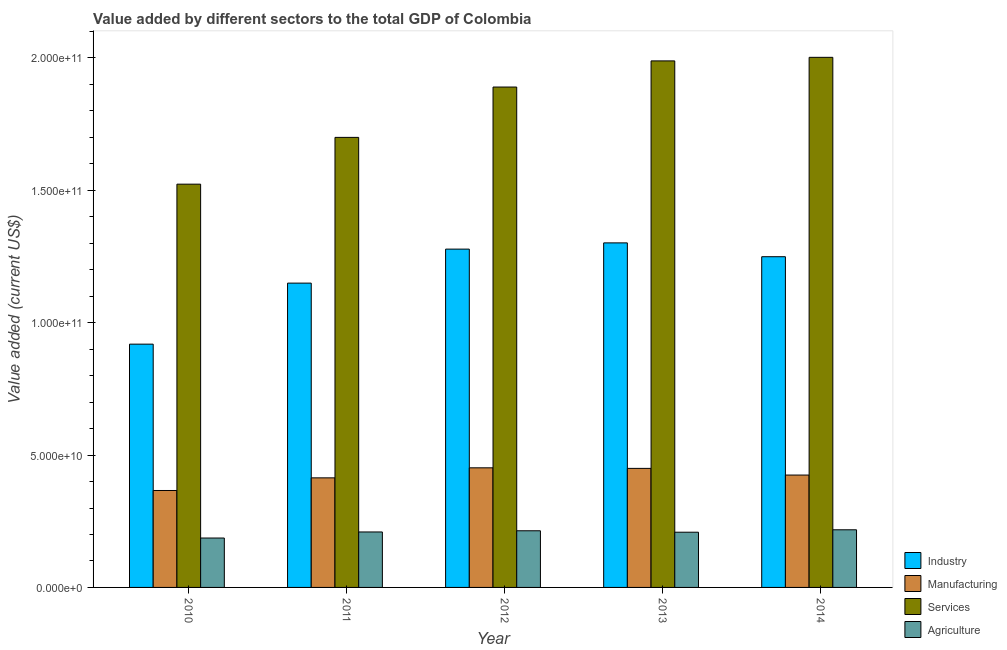How many different coloured bars are there?
Ensure brevity in your answer.  4. How many groups of bars are there?
Make the answer very short. 5. Are the number of bars on each tick of the X-axis equal?
Provide a short and direct response. Yes. How many bars are there on the 3rd tick from the left?
Your answer should be very brief. 4. How many bars are there on the 5th tick from the right?
Give a very brief answer. 4. What is the label of the 1st group of bars from the left?
Ensure brevity in your answer.  2010. In how many cases, is the number of bars for a given year not equal to the number of legend labels?
Provide a short and direct response. 0. What is the value added by agricultural sector in 2013?
Your answer should be compact. 2.09e+1. Across all years, what is the maximum value added by agricultural sector?
Your response must be concise. 2.18e+1. Across all years, what is the minimum value added by services sector?
Make the answer very short. 1.52e+11. What is the total value added by industrial sector in the graph?
Make the answer very short. 5.90e+11. What is the difference between the value added by services sector in 2010 and that in 2013?
Keep it short and to the point. -4.66e+1. What is the difference between the value added by agricultural sector in 2014 and the value added by services sector in 2011?
Keep it short and to the point. 8.23e+08. What is the average value added by services sector per year?
Provide a succinct answer. 1.82e+11. In the year 2012, what is the difference between the value added by agricultural sector and value added by industrial sector?
Make the answer very short. 0. In how many years, is the value added by agricultural sector greater than 60000000000 US$?
Give a very brief answer. 0. What is the ratio of the value added by manufacturing sector in 2011 to that in 2014?
Your answer should be compact. 0.98. What is the difference between the highest and the second highest value added by agricultural sector?
Provide a short and direct response. 3.77e+08. What is the difference between the highest and the lowest value added by industrial sector?
Keep it short and to the point. 3.83e+1. In how many years, is the value added by agricultural sector greater than the average value added by agricultural sector taken over all years?
Give a very brief answer. 4. Is the sum of the value added by industrial sector in 2011 and 2013 greater than the maximum value added by agricultural sector across all years?
Give a very brief answer. Yes. Is it the case that in every year, the sum of the value added by agricultural sector and value added by industrial sector is greater than the sum of value added by manufacturing sector and value added by services sector?
Your answer should be very brief. No. What does the 3rd bar from the left in 2010 represents?
Provide a short and direct response. Services. What does the 3rd bar from the right in 2011 represents?
Give a very brief answer. Manufacturing. How many years are there in the graph?
Ensure brevity in your answer.  5. What is the difference between two consecutive major ticks on the Y-axis?
Make the answer very short. 5.00e+1. Does the graph contain any zero values?
Give a very brief answer. No. Where does the legend appear in the graph?
Ensure brevity in your answer.  Bottom right. What is the title of the graph?
Make the answer very short. Value added by different sectors to the total GDP of Colombia. Does "Public sector management" appear as one of the legend labels in the graph?
Make the answer very short. No. What is the label or title of the Y-axis?
Offer a very short reply. Value added (current US$). What is the Value added (current US$) of Industry in 2010?
Your answer should be compact. 9.19e+1. What is the Value added (current US$) in Manufacturing in 2010?
Keep it short and to the point. 3.66e+1. What is the Value added (current US$) of Services in 2010?
Offer a very short reply. 1.52e+11. What is the Value added (current US$) in Agriculture in 2010?
Provide a short and direct response. 1.87e+1. What is the Value added (current US$) in Industry in 2011?
Provide a succinct answer. 1.15e+11. What is the Value added (current US$) in Manufacturing in 2011?
Provide a short and direct response. 4.14e+1. What is the Value added (current US$) of Services in 2011?
Keep it short and to the point. 1.70e+11. What is the Value added (current US$) of Agriculture in 2011?
Offer a terse response. 2.10e+1. What is the Value added (current US$) of Industry in 2012?
Ensure brevity in your answer.  1.28e+11. What is the Value added (current US$) in Manufacturing in 2012?
Offer a very short reply. 4.52e+1. What is the Value added (current US$) of Services in 2012?
Offer a very short reply. 1.89e+11. What is the Value added (current US$) of Agriculture in 2012?
Your answer should be very brief. 2.14e+1. What is the Value added (current US$) of Industry in 2013?
Your response must be concise. 1.30e+11. What is the Value added (current US$) in Manufacturing in 2013?
Make the answer very short. 4.50e+1. What is the Value added (current US$) of Services in 2013?
Your response must be concise. 1.99e+11. What is the Value added (current US$) of Agriculture in 2013?
Ensure brevity in your answer.  2.09e+1. What is the Value added (current US$) of Industry in 2014?
Your answer should be compact. 1.25e+11. What is the Value added (current US$) of Manufacturing in 2014?
Give a very brief answer. 4.25e+1. What is the Value added (current US$) of Services in 2014?
Your response must be concise. 2.00e+11. What is the Value added (current US$) in Agriculture in 2014?
Your answer should be compact. 2.18e+1. Across all years, what is the maximum Value added (current US$) of Industry?
Offer a terse response. 1.30e+11. Across all years, what is the maximum Value added (current US$) of Manufacturing?
Your answer should be very brief. 4.52e+1. Across all years, what is the maximum Value added (current US$) in Services?
Your answer should be very brief. 2.00e+11. Across all years, what is the maximum Value added (current US$) of Agriculture?
Provide a short and direct response. 2.18e+1. Across all years, what is the minimum Value added (current US$) of Industry?
Offer a very short reply. 9.19e+1. Across all years, what is the minimum Value added (current US$) in Manufacturing?
Give a very brief answer. 3.66e+1. Across all years, what is the minimum Value added (current US$) of Services?
Your response must be concise. 1.52e+11. Across all years, what is the minimum Value added (current US$) in Agriculture?
Keep it short and to the point. 1.87e+1. What is the total Value added (current US$) of Industry in the graph?
Your answer should be very brief. 5.90e+11. What is the total Value added (current US$) in Manufacturing in the graph?
Provide a short and direct response. 2.11e+11. What is the total Value added (current US$) in Services in the graph?
Offer a terse response. 9.11e+11. What is the total Value added (current US$) in Agriculture in the graph?
Give a very brief answer. 1.04e+11. What is the difference between the Value added (current US$) of Industry in 2010 and that in 2011?
Ensure brevity in your answer.  -2.31e+1. What is the difference between the Value added (current US$) of Manufacturing in 2010 and that in 2011?
Offer a terse response. -4.77e+09. What is the difference between the Value added (current US$) of Services in 2010 and that in 2011?
Provide a succinct answer. -1.77e+1. What is the difference between the Value added (current US$) in Agriculture in 2010 and that in 2011?
Keep it short and to the point. -2.29e+09. What is the difference between the Value added (current US$) in Industry in 2010 and that in 2012?
Give a very brief answer. -3.59e+1. What is the difference between the Value added (current US$) of Manufacturing in 2010 and that in 2012?
Offer a terse response. -8.56e+09. What is the difference between the Value added (current US$) in Services in 2010 and that in 2012?
Make the answer very short. -3.67e+1. What is the difference between the Value added (current US$) in Agriculture in 2010 and that in 2012?
Offer a very short reply. -2.74e+09. What is the difference between the Value added (current US$) of Industry in 2010 and that in 2013?
Provide a short and direct response. -3.83e+1. What is the difference between the Value added (current US$) of Manufacturing in 2010 and that in 2013?
Ensure brevity in your answer.  -8.35e+09. What is the difference between the Value added (current US$) of Services in 2010 and that in 2013?
Offer a very short reply. -4.66e+1. What is the difference between the Value added (current US$) of Agriculture in 2010 and that in 2013?
Provide a succinct answer. -2.20e+09. What is the difference between the Value added (current US$) in Industry in 2010 and that in 2014?
Ensure brevity in your answer.  -3.30e+1. What is the difference between the Value added (current US$) in Manufacturing in 2010 and that in 2014?
Offer a very short reply. -5.83e+09. What is the difference between the Value added (current US$) of Services in 2010 and that in 2014?
Offer a very short reply. -4.79e+1. What is the difference between the Value added (current US$) of Agriculture in 2010 and that in 2014?
Provide a succinct answer. -3.11e+09. What is the difference between the Value added (current US$) of Industry in 2011 and that in 2012?
Provide a succinct answer. -1.28e+1. What is the difference between the Value added (current US$) of Manufacturing in 2011 and that in 2012?
Provide a short and direct response. -3.79e+09. What is the difference between the Value added (current US$) in Services in 2011 and that in 2012?
Your response must be concise. -1.90e+1. What is the difference between the Value added (current US$) of Agriculture in 2011 and that in 2012?
Your response must be concise. -4.47e+08. What is the difference between the Value added (current US$) in Industry in 2011 and that in 2013?
Provide a succinct answer. -1.52e+1. What is the difference between the Value added (current US$) of Manufacturing in 2011 and that in 2013?
Offer a very short reply. -3.58e+09. What is the difference between the Value added (current US$) of Services in 2011 and that in 2013?
Make the answer very short. -2.89e+1. What is the difference between the Value added (current US$) in Agriculture in 2011 and that in 2013?
Offer a very short reply. 9.45e+07. What is the difference between the Value added (current US$) of Industry in 2011 and that in 2014?
Your answer should be very brief. -9.98e+09. What is the difference between the Value added (current US$) of Manufacturing in 2011 and that in 2014?
Your answer should be compact. -1.06e+09. What is the difference between the Value added (current US$) of Services in 2011 and that in 2014?
Provide a short and direct response. -3.02e+1. What is the difference between the Value added (current US$) of Agriculture in 2011 and that in 2014?
Offer a very short reply. -8.23e+08. What is the difference between the Value added (current US$) in Industry in 2012 and that in 2013?
Provide a succinct answer. -2.36e+09. What is the difference between the Value added (current US$) in Manufacturing in 2012 and that in 2013?
Give a very brief answer. 2.10e+08. What is the difference between the Value added (current US$) in Services in 2012 and that in 2013?
Your answer should be compact. -9.87e+09. What is the difference between the Value added (current US$) of Agriculture in 2012 and that in 2013?
Provide a short and direct response. 5.41e+08. What is the difference between the Value added (current US$) in Industry in 2012 and that in 2014?
Offer a very short reply. 2.87e+09. What is the difference between the Value added (current US$) in Manufacturing in 2012 and that in 2014?
Offer a very short reply. 2.73e+09. What is the difference between the Value added (current US$) of Services in 2012 and that in 2014?
Make the answer very short. -1.12e+1. What is the difference between the Value added (current US$) in Agriculture in 2012 and that in 2014?
Ensure brevity in your answer.  -3.77e+08. What is the difference between the Value added (current US$) of Industry in 2013 and that in 2014?
Make the answer very short. 5.22e+09. What is the difference between the Value added (current US$) in Manufacturing in 2013 and that in 2014?
Your answer should be compact. 2.52e+09. What is the difference between the Value added (current US$) in Services in 2013 and that in 2014?
Keep it short and to the point. -1.35e+09. What is the difference between the Value added (current US$) in Agriculture in 2013 and that in 2014?
Provide a succinct answer. -9.18e+08. What is the difference between the Value added (current US$) of Industry in 2010 and the Value added (current US$) of Manufacturing in 2011?
Provide a short and direct response. 5.05e+1. What is the difference between the Value added (current US$) in Industry in 2010 and the Value added (current US$) in Services in 2011?
Provide a succinct answer. -7.81e+1. What is the difference between the Value added (current US$) in Industry in 2010 and the Value added (current US$) in Agriculture in 2011?
Provide a short and direct response. 7.10e+1. What is the difference between the Value added (current US$) in Manufacturing in 2010 and the Value added (current US$) in Services in 2011?
Ensure brevity in your answer.  -1.33e+11. What is the difference between the Value added (current US$) of Manufacturing in 2010 and the Value added (current US$) of Agriculture in 2011?
Your answer should be compact. 1.57e+1. What is the difference between the Value added (current US$) of Services in 2010 and the Value added (current US$) of Agriculture in 2011?
Keep it short and to the point. 1.31e+11. What is the difference between the Value added (current US$) of Industry in 2010 and the Value added (current US$) of Manufacturing in 2012?
Keep it short and to the point. 4.67e+1. What is the difference between the Value added (current US$) in Industry in 2010 and the Value added (current US$) in Services in 2012?
Make the answer very short. -9.71e+1. What is the difference between the Value added (current US$) of Industry in 2010 and the Value added (current US$) of Agriculture in 2012?
Offer a very short reply. 7.05e+1. What is the difference between the Value added (current US$) of Manufacturing in 2010 and the Value added (current US$) of Services in 2012?
Offer a terse response. -1.52e+11. What is the difference between the Value added (current US$) of Manufacturing in 2010 and the Value added (current US$) of Agriculture in 2012?
Offer a terse response. 1.52e+1. What is the difference between the Value added (current US$) in Services in 2010 and the Value added (current US$) in Agriculture in 2012?
Provide a succinct answer. 1.31e+11. What is the difference between the Value added (current US$) in Industry in 2010 and the Value added (current US$) in Manufacturing in 2013?
Provide a succinct answer. 4.69e+1. What is the difference between the Value added (current US$) of Industry in 2010 and the Value added (current US$) of Services in 2013?
Keep it short and to the point. -1.07e+11. What is the difference between the Value added (current US$) in Industry in 2010 and the Value added (current US$) in Agriculture in 2013?
Offer a terse response. 7.10e+1. What is the difference between the Value added (current US$) in Manufacturing in 2010 and the Value added (current US$) in Services in 2013?
Your response must be concise. -1.62e+11. What is the difference between the Value added (current US$) of Manufacturing in 2010 and the Value added (current US$) of Agriculture in 2013?
Your response must be concise. 1.58e+1. What is the difference between the Value added (current US$) in Services in 2010 and the Value added (current US$) in Agriculture in 2013?
Your answer should be very brief. 1.31e+11. What is the difference between the Value added (current US$) of Industry in 2010 and the Value added (current US$) of Manufacturing in 2014?
Ensure brevity in your answer.  4.95e+1. What is the difference between the Value added (current US$) in Industry in 2010 and the Value added (current US$) in Services in 2014?
Provide a short and direct response. -1.08e+11. What is the difference between the Value added (current US$) of Industry in 2010 and the Value added (current US$) of Agriculture in 2014?
Provide a short and direct response. 7.01e+1. What is the difference between the Value added (current US$) in Manufacturing in 2010 and the Value added (current US$) in Services in 2014?
Offer a terse response. -1.64e+11. What is the difference between the Value added (current US$) of Manufacturing in 2010 and the Value added (current US$) of Agriculture in 2014?
Offer a terse response. 1.48e+1. What is the difference between the Value added (current US$) of Services in 2010 and the Value added (current US$) of Agriculture in 2014?
Make the answer very short. 1.31e+11. What is the difference between the Value added (current US$) of Industry in 2011 and the Value added (current US$) of Manufacturing in 2012?
Give a very brief answer. 6.98e+1. What is the difference between the Value added (current US$) in Industry in 2011 and the Value added (current US$) in Services in 2012?
Provide a short and direct response. -7.41e+1. What is the difference between the Value added (current US$) of Industry in 2011 and the Value added (current US$) of Agriculture in 2012?
Offer a terse response. 9.36e+1. What is the difference between the Value added (current US$) of Manufacturing in 2011 and the Value added (current US$) of Services in 2012?
Keep it short and to the point. -1.48e+11. What is the difference between the Value added (current US$) of Manufacturing in 2011 and the Value added (current US$) of Agriculture in 2012?
Provide a short and direct response. 2.00e+1. What is the difference between the Value added (current US$) of Services in 2011 and the Value added (current US$) of Agriculture in 2012?
Ensure brevity in your answer.  1.49e+11. What is the difference between the Value added (current US$) of Industry in 2011 and the Value added (current US$) of Manufacturing in 2013?
Make the answer very short. 7.00e+1. What is the difference between the Value added (current US$) in Industry in 2011 and the Value added (current US$) in Services in 2013?
Provide a short and direct response. -8.39e+1. What is the difference between the Value added (current US$) of Industry in 2011 and the Value added (current US$) of Agriculture in 2013?
Keep it short and to the point. 9.41e+1. What is the difference between the Value added (current US$) in Manufacturing in 2011 and the Value added (current US$) in Services in 2013?
Give a very brief answer. -1.58e+11. What is the difference between the Value added (current US$) in Manufacturing in 2011 and the Value added (current US$) in Agriculture in 2013?
Keep it short and to the point. 2.05e+1. What is the difference between the Value added (current US$) of Services in 2011 and the Value added (current US$) of Agriculture in 2013?
Offer a terse response. 1.49e+11. What is the difference between the Value added (current US$) in Industry in 2011 and the Value added (current US$) in Manufacturing in 2014?
Make the answer very short. 7.25e+1. What is the difference between the Value added (current US$) in Industry in 2011 and the Value added (current US$) in Services in 2014?
Your response must be concise. -8.53e+1. What is the difference between the Value added (current US$) in Industry in 2011 and the Value added (current US$) in Agriculture in 2014?
Ensure brevity in your answer.  9.32e+1. What is the difference between the Value added (current US$) of Manufacturing in 2011 and the Value added (current US$) of Services in 2014?
Provide a succinct answer. -1.59e+11. What is the difference between the Value added (current US$) in Manufacturing in 2011 and the Value added (current US$) in Agriculture in 2014?
Offer a very short reply. 1.96e+1. What is the difference between the Value added (current US$) of Services in 2011 and the Value added (current US$) of Agriculture in 2014?
Your response must be concise. 1.48e+11. What is the difference between the Value added (current US$) of Industry in 2012 and the Value added (current US$) of Manufacturing in 2013?
Make the answer very short. 8.28e+1. What is the difference between the Value added (current US$) in Industry in 2012 and the Value added (current US$) in Services in 2013?
Your answer should be compact. -7.11e+1. What is the difference between the Value added (current US$) of Industry in 2012 and the Value added (current US$) of Agriculture in 2013?
Make the answer very short. 1.07e+11. What is the difference between the Value added (current US$) in Manufacturing in 2012 and the Value added (current US$) in Services in 2013?
Your answer should be very brief. -1.54e+11. What is the difference between the Value added (current US$) in Manufacturing in 2012 and the Value added (current US$) in Agriculture in 2013?
Keep it short and to the point. 2.43e+1. What is the difference between the Value added (current US$) in Services in 2012 and the Value added (current US$) in Agriculture in 2013?
Your answer should be compact. 1.68e+11. What is the difference between the Value added (current US$) in Industry in 2012 and the Value added (current US$) in Manufacturing in 2014?
Ensure brevity in your answer.  8.53e+1. What is the difference between the Value added (current US$) of Industry in 2012 and the Value added (current US$) of Services in 2014?
Offer a very short reply. -7.25e+1. What is the difference between the Value added (current US$) in Industry in 2012 and the Value added (current US$) in Agriculture in 2014?
Ensure brevity in your answer.  1.06e+11. What is the difference between the Value added (current US$) of Manufacturing in 2012 and the Value added (current US$) of Services in 2014?
Keep it short and to the point. -1.55e+11. What is the difference between the Value added (current US$) in Manufacturing in 2012 and the Value added (current US$) in Agriculture in 2014?
Your answer should be compact. 2.34e+1. What is the difference between the Value added (current US$) in Services in 2012 and the Value added (current US$) in Agriculture in 2014?
Your answer should be very brief. 1.67e+11. What is the difference between the Value added (current US$) of Industry in 2013 and the Value added (current US$) of Manufacturing in 2014?
Your response must be concise. 8.77e+1. What is the difference between the Value added (current US$) of Industry in 2013 and the Value added (current US$) of Services in 2014?
Your answer should be very brief. -7.01e+1. What is the difference between the Value added (current US$) in Industry in 2013 and the Value added (current US$) in Agriculture in 2014?
Provide a short and direct response. 1.08e+11. What is the difference between the Value added (current US$) of Manufacturing in 2013 and the Value added (current US$) of Services in 2014?
Your answer should be compact. -1.55e+11. What is the difference between the Value added (current US$) of Manufacturing in 2013 and the Value added (current US$) of Agriculture in 2014?
Your answer should be very brief. 2.32e+1. What is the difference between the Value added (current US$) of Services in 2013 and the Value added (current US$) of Agriculture in 2014?
Your answer should be compact. 1.77e+11. What is the average Value added (current US$) of Industry per year?
Offer a terse response. 1.18e+11. What is the average Value added (current US$) in Manufacturing per year?
Provide a succinct answer. 4.21e+1. What is the average Value added (current US$) of Services per year?
Provide a succinct answer. 1.82e+11. What is the average Value added (current US$) of Agriculture per year?
Offer a terse response. 2.07e+1. In the year 2010, what is the difference between the Value added (current US$) in Industry and Value added (current US$) in Manufacturing?
Keep it short and to the point. 5.53e+1. In the year 2010, what is the difference between the Value added (current US$) in Industry and Value added (current US$) in Services?
Offer a terse response. -6.04e+1. In the year 2010, what is the difference between the Value added (current US$) in Industry and Value added (current US$) in Agriculture?
Your answer should be very brief. 7.32e+1. In the year 2010, what is the difference between the Value added (current US$) of Manufacturing and Value added (current US$) of Services?
Offer a very short reply. -1.16e+11. In the year 2010, what is the difference between the Value added (current US$) in Manufacturing and Value added (current US$) in Agriculture?
Keep it short and to the point. 1.80e+1. In the year 2010, what is the difference between the Value added (current US$) of Services and Value added (current US$) of Agriculture?
Provide a short and direct response. 1.34e+11. In the year 2011, what is the difference between the Value added (current US$) of Industry and Value added (current US$) of Manufacturing?
Provide a short and direct response. 7.36e+1. In the year 2011, what is the difference between the Value added (current US$) in Industry and Value added (current US$) in Services?
Keep it short and to the point. -5.51e+1. In the year 2011, what is the difference between the Value added (current US$) in Industry and Value added (current US$) in Agriculture?
Your answer should be very brief. 9.40e+1. In the year 2011, what is the difference between the Value added (current US$) in Manufacturing and Value added (current US$) in Services?
Provide a short and direct response. -1.29e+11. In the year 2011, what is the difference between the Value added (current US$) of Manufacturing and Value added (current US$) of Agriculture?
Give a very brief answer. 2.04e+1. In the year 2011, what is the difference between the Value added (current US$) of Services and Value added (current US$) of Agriculture?
Ensure brevity in your answer.  1.49e+11. In the year 2012, what is the difference between the Value added (current US$) in Industry and Value added (current US$) in Manufacturing?
Offer a terse response. 8.26e+1. In the year 2012, what is the difference between the Value added (current US$) in Industry and Value added (current US$) in Services?
Make the answer very short. -6.12e+1. In the year 2012, what is the difference between the Value added (current US$) in Industry and Value added (current US$) in Agriculture?
Offer a terse response. 1.06e+11. In the year 2012, what is the difference between the Value added (current US$) of Manufacturing and Value added (current US$) of Services?
Provide a succinct answer. -1.44e+11. In the year 2012, what is the difference between the Value added (current US$) in Manufacturing and Value added (current US$) in Agriculture?
Your answer should be compact. 2.38e+1. In the year 2012, what is the difference between the Value added (current US$) in Services and Value added (current US$) in Agriculture?
Offer a very short reply. 1.68e+11. In the year 2013, what is the difference between the Value added (current US$) in Industry and Value added (current US$) in Manufacturing?
Offer a terse response. 8.52e+1. In the year 2013, what is the difference between the Value added (current US$) in Industry and Value added (current US$) in Services?
Provide a succinct answer. -6.87e+1. In the year 2013, what is the difference between the Value added (current US$) in Industry and Value added (current US$) in Agriculture?
Give a very brief answer. 1.09e+11. In the year 2013, what is the difference between the Value added (current US$) of Manufacturing and Value added (current US$) of Services?
Your answer should be compact. -1.54e+11. In the year 2013, what is the difference between the Value added (current US$) in Manufacturing and Value added (current US$) in Agriculture?
Your answer should be very brief. 2.41e+1. In the year 2013, what is the difference between the Value added (current US$) in Services and Value added (current US$) in Agriculture?
Offer a terse response. 1.78e+11. In the year 2014, what is the difference between the Value added (current US$) in Industry and Value added (current US$) in Manufacturing?
Make the answer very short. 8.25e+1. In the year 2014, what is the difference between the Value added (current US$) in Industry and Value added (current US$) in Services?
Offer a terse response. -7.53e+1. In the year 2014, what is the difference between the Value added (current US$) of Industry and Value added (current US$) of Agriculture?
Your answer should be very brief. 1.03e+11. In the year 2014, what is the difference between the Value added (current US$) in Manufacturing and Value added (current US$) in Services?
Keep it short and to the point. -1.58e+11. In the year 2014, what is the difference between the Value added (current US$) of Manufacturing and Value added (current US$) of Agriculture?
Your answer should be very brief. 2.07e+1. In the year 2014, what is the difference between the Value added (current US$) of Services and Value added (current US$) of Agriculture?
Give a very brief answer. 1.78e+11. What is the ratio of the Value added (current US$) in Industry in 2010 to that in 2011?
Offer a very short reply. 0.8. What is the ratio of the Value added (current US$) of Manufacturing in 2010 to that in 2011?
Your answer should be very brief. 0.88. What is the ratio of the Value added (current US$) of Services in 2010 to that in 2011?
Give a very brief answer. 0.9. What is the ratio of the Value added (current US$) of Agriculture in 2010 to that in 2011?
Make the answer very short. 0.89. What is the ratio of the Value added (current US$) in Industry in 2010 to that in 2012?
Offer a very short reply. 0.72. What is the ratio of the Value added (current US$) of Manufacturing in 2010 to that in 2012?
Offer a terse response. 0.81. What is the ratio of the Value added (current US$) in Services in 2010 to that in 2012?
Your response must be concise. 0.81. What is the ratio of the Value added (current US$) in Agriculture in 2010 to that in 2012?
Ensure brevity in your answer.  0.87. What is the ratio of the Value added (current US$) of Industry in 2010 to that in 2013?
Your response must be concise. 0.71. What is the ratio of the Value added (current US$) of Manufacturing in 2010 to that in 2013?
Provide a short and direct response. 0.81. What is the ratio of the Value added (current US$) of Services in 2010 to that in 2013?
Make the answer very short. 0.77. What is the ratio of the Value added (current US$) in Agriculture in 2010 to that in 2013?
Provide a short and direct response. 0.89. What is the ratio of the Value added (current US$) of Industry in 2010 to that in 2014?
Your answer should be compact. 0.74. What is the ratio of the Value added (current US$) in Manufacturing in 2010 to that in 2014?
Your response must be concise. 0.86. What is the ratio of the Value added (current US$) in Services in 2010 to that in 2014?
Provide a succinct answer. 0.76. What is the ratio of the Value added (current US$) in Agriculture in 2010 to that in 2014?
Ensure brevity in your answer.  0.86. What is the ratio of the Value added (current US$) in Industry in 2011 to that in 2012?
Your answer should be very brief. 0.9. What is the ratio of the Value added (current US$) of Manufacturing in 2011 to that in 2012?
Your answer should be very brief. 0.92. What is the ratio of the Value added (current US$) of Services in 2011 to that in 2012?
Make the answer very short. 0.9. What is the ratio of the Value added (current US$) in Agriculture in 2011 to that in 2012?
Make the answer very short. 0.98. What is the ratio of the Value added (current US$) in Industry in 2011 to that in 2013?
Ensure brevity in your answer.  0.88. What is the ratio of the Value added (current US$) in Manufacturing in 2011 to that in 2013?
Provide a succinct answer. 0.92. What is the ratio of the Value added (current US$) in Services in 2011 to that in 2013?
Give a very brief answer. 0.85. What is the ratio of the Value added (current US$) of Agriculture in 2011 to that in 2013?
Your response must be concise. 1. What is the ratio of the Value added (current US$) of Industry in 2011 to that in 2014?
Offer a terse response. 0.92. What is the ratio of the Value added (current US$) in Manufacturing in 2011 to that in 2014?
Offer a very short reply. 0.97. What is the ratio of the Value added (current US$) in Services in 2011 to that in 2014?
Keep it short and to the point. 0.85. What is the ratio of the Value added (current US$) in Agriculture in 2011 to that in 2014?
Make the answer very short. 0.96. What is the ratio of the Value added (current US$) in Industry in 2012 to that in 2013?
Your response must be concise. 0.98. What is the ratio of the Value added (current US$) of Services in 2012 to that in 2013?
Offer a terse response. 0.95. What is the ratio of the Value added (current US$) of Agriculture in 2012 to that in 2013?
Offer a very short reply. 1.03. What is the ratio of the Value added (current US$) of Industry in 2012 to that in 2014?
Offer a very short reply. 1.02. What is the ratio of the Value added (current US$) of Manufacturing in 2012 to that in 2014?
Ensure brevity in your answer.  1.06. What is the ratio of the Value added (current US$) in Services in 2012 to that in 2014?
Your answer should be compact. 0.94. What is the ratio of the Value added (current US$) of Agriculture in 2012 to that in 2014?
Give a very brief answer. 0.98. What is the ratio of the Value added (current US$) in Industry in 2013 to that in 2014?
Keep it short and to the point. 1.04. What is the ratio of the Value added (current US$) of Manufacturing in 2013 to that in 2014?
Ensure brevity in your answer.  1.06. What is the ratio of the Value added (current US$) of Agriculture in 2013 to that in 2014?
Provide a succinct answer. 0.96. What is the difference between the highest and the second highest Value added (current US$) of Industry?
Provide a succinct answer. 2.36e+09. What is the difference between the highest and the second highest Value added (current US$) in Manufacturing?
Provide a short and direct response. 2.10e+08. What is the difference between the highest and the second highest Value added (current US$) in Services?
Offer a terse response. 1.35e+09. What is the difference between the highest and the second highest Value added (current US$) of Agriculture?
Your answer should be compact. 3.77e+08. What is the difference between the highest and the lowest Value added (current US$) in Industry?
Keep it short and to the point. 3.83e+1. What is the difference between the highest and the lowest Value added (current US$) in Manufacturing?
Your answer should be compact. 8.56e+09. What is the difference between the highest and the lowest Value added (current US$) of Services?
Your response must be concise. 4.79e+1. What is the difference between the highest and the lowest Value added (current US$) of Agriculture?
Provide a short and direct response. 3.11e+09. 